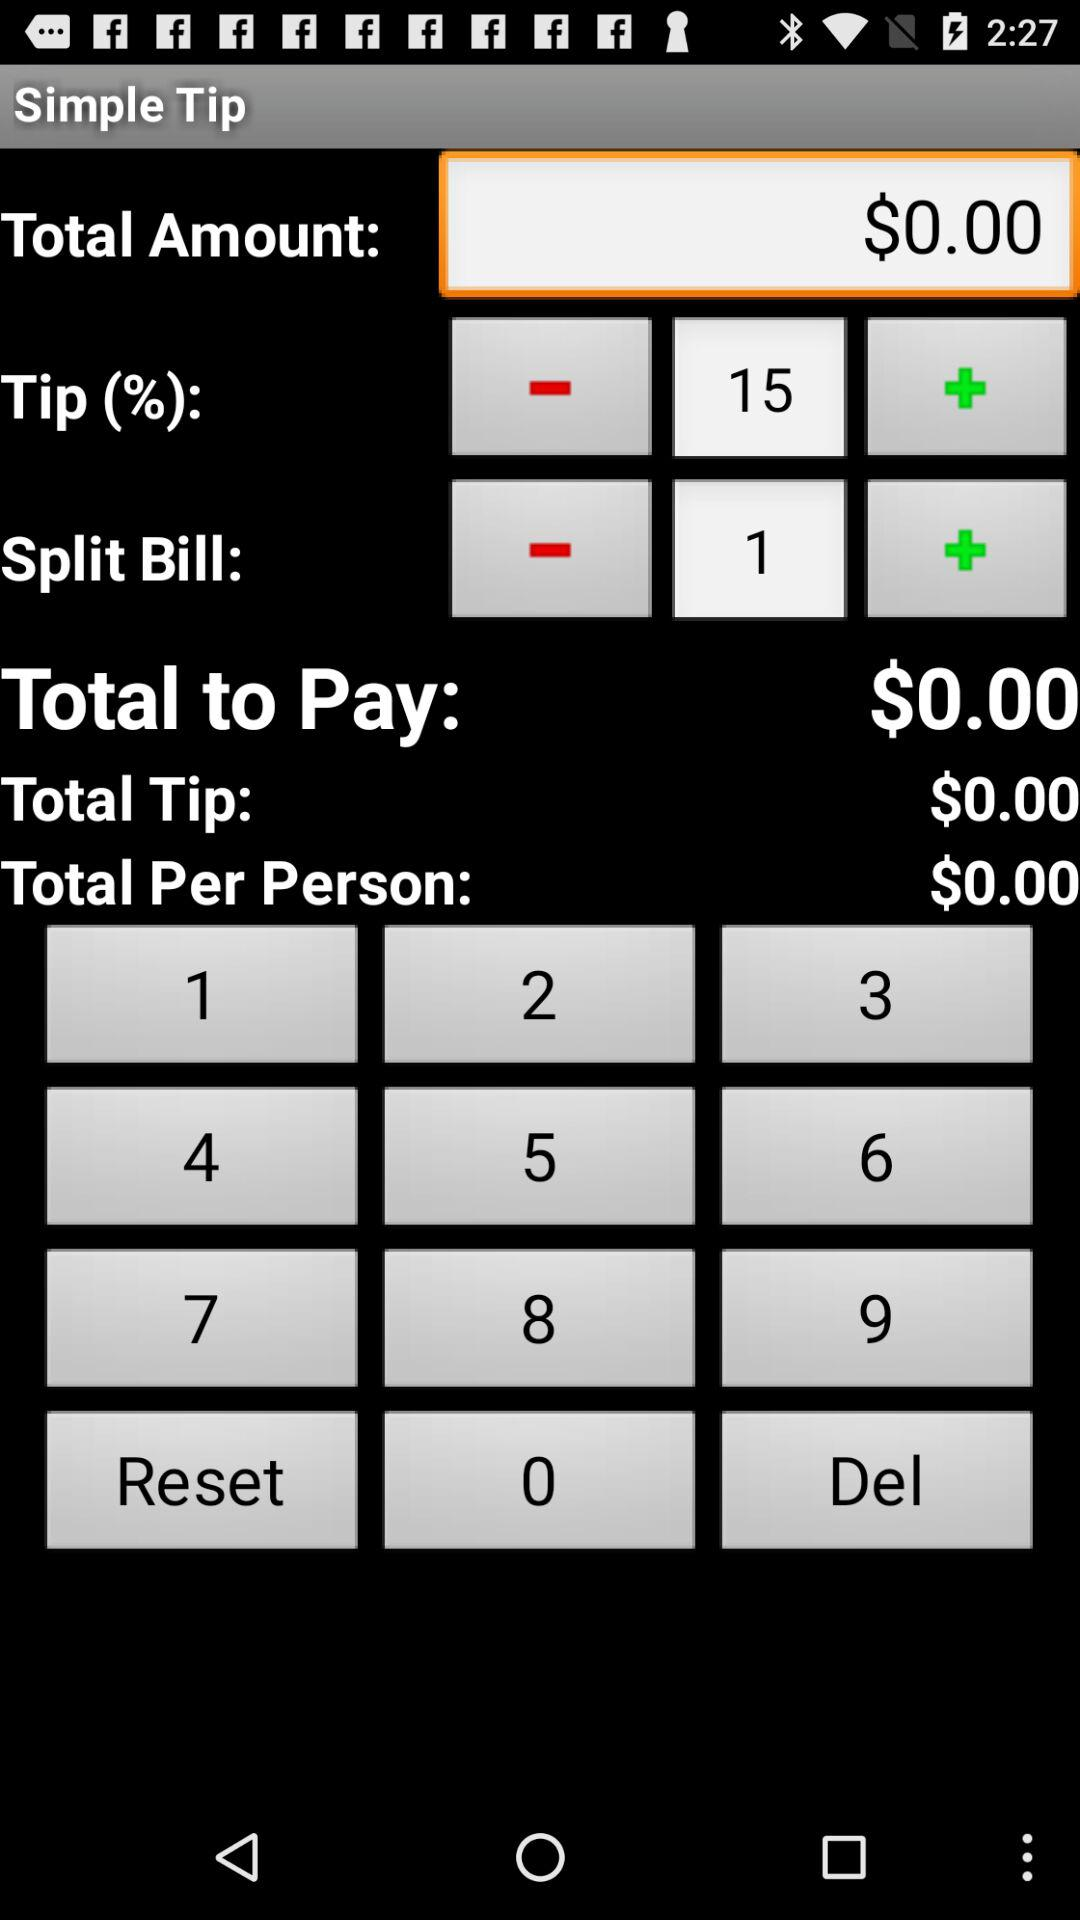How much is the total amount? The total amount is $0.00. 